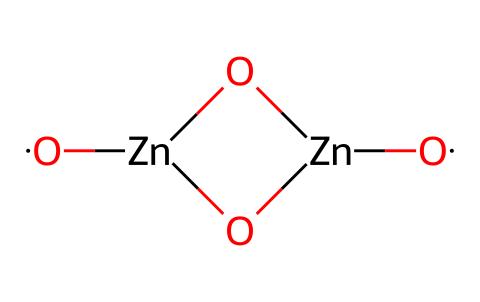What is the central metal in this chemical structure? Analyzing the SMILES representation, the central metal atom is denoted by [Zn], which indicates that zinc is present. The structural arrangement consists of zinc atoms connected through oxygen atoms.
Answer: zinc How many oxygen atoms are present? By examining the SMILES notation, there are four [O] representations indicating the presence of four oxygen atoms in the compound.
Answer: four What type of structure does this chemical represent? The arrangement combines zinc and oxygen in a coordinated network, typical of metal oxide quantum dots. Specifically, this structure forms a particulate that exhibits quantum confinement properties.
Answer: metal oxide quantum dots Can this quantum dot structure contribute to UV protection? The configuration of zinc oxide can absorb UV light, making it effective for UV protection, commonly used in applications like coatings and fabrics to shield against harmful sunlight.
Answer: yes What is a significant property of zinc oxide quantum dots in swimwear? Zinc oxide quantum dots are known for their antibacterial and UV-blocking properties, which enhance the longevity and safety of swimwear materials.
Answer: antibacterial and UV-blocking properties What feature suggests this compound is suitable for eco-friendly applications? The use of zinc oxide, a naturally occurring compound with non-toxic properties, along with its ability to provide protection, suggests that it aligns with eco-friendly manufacturing practices.
Answer: non-toxic and protective 